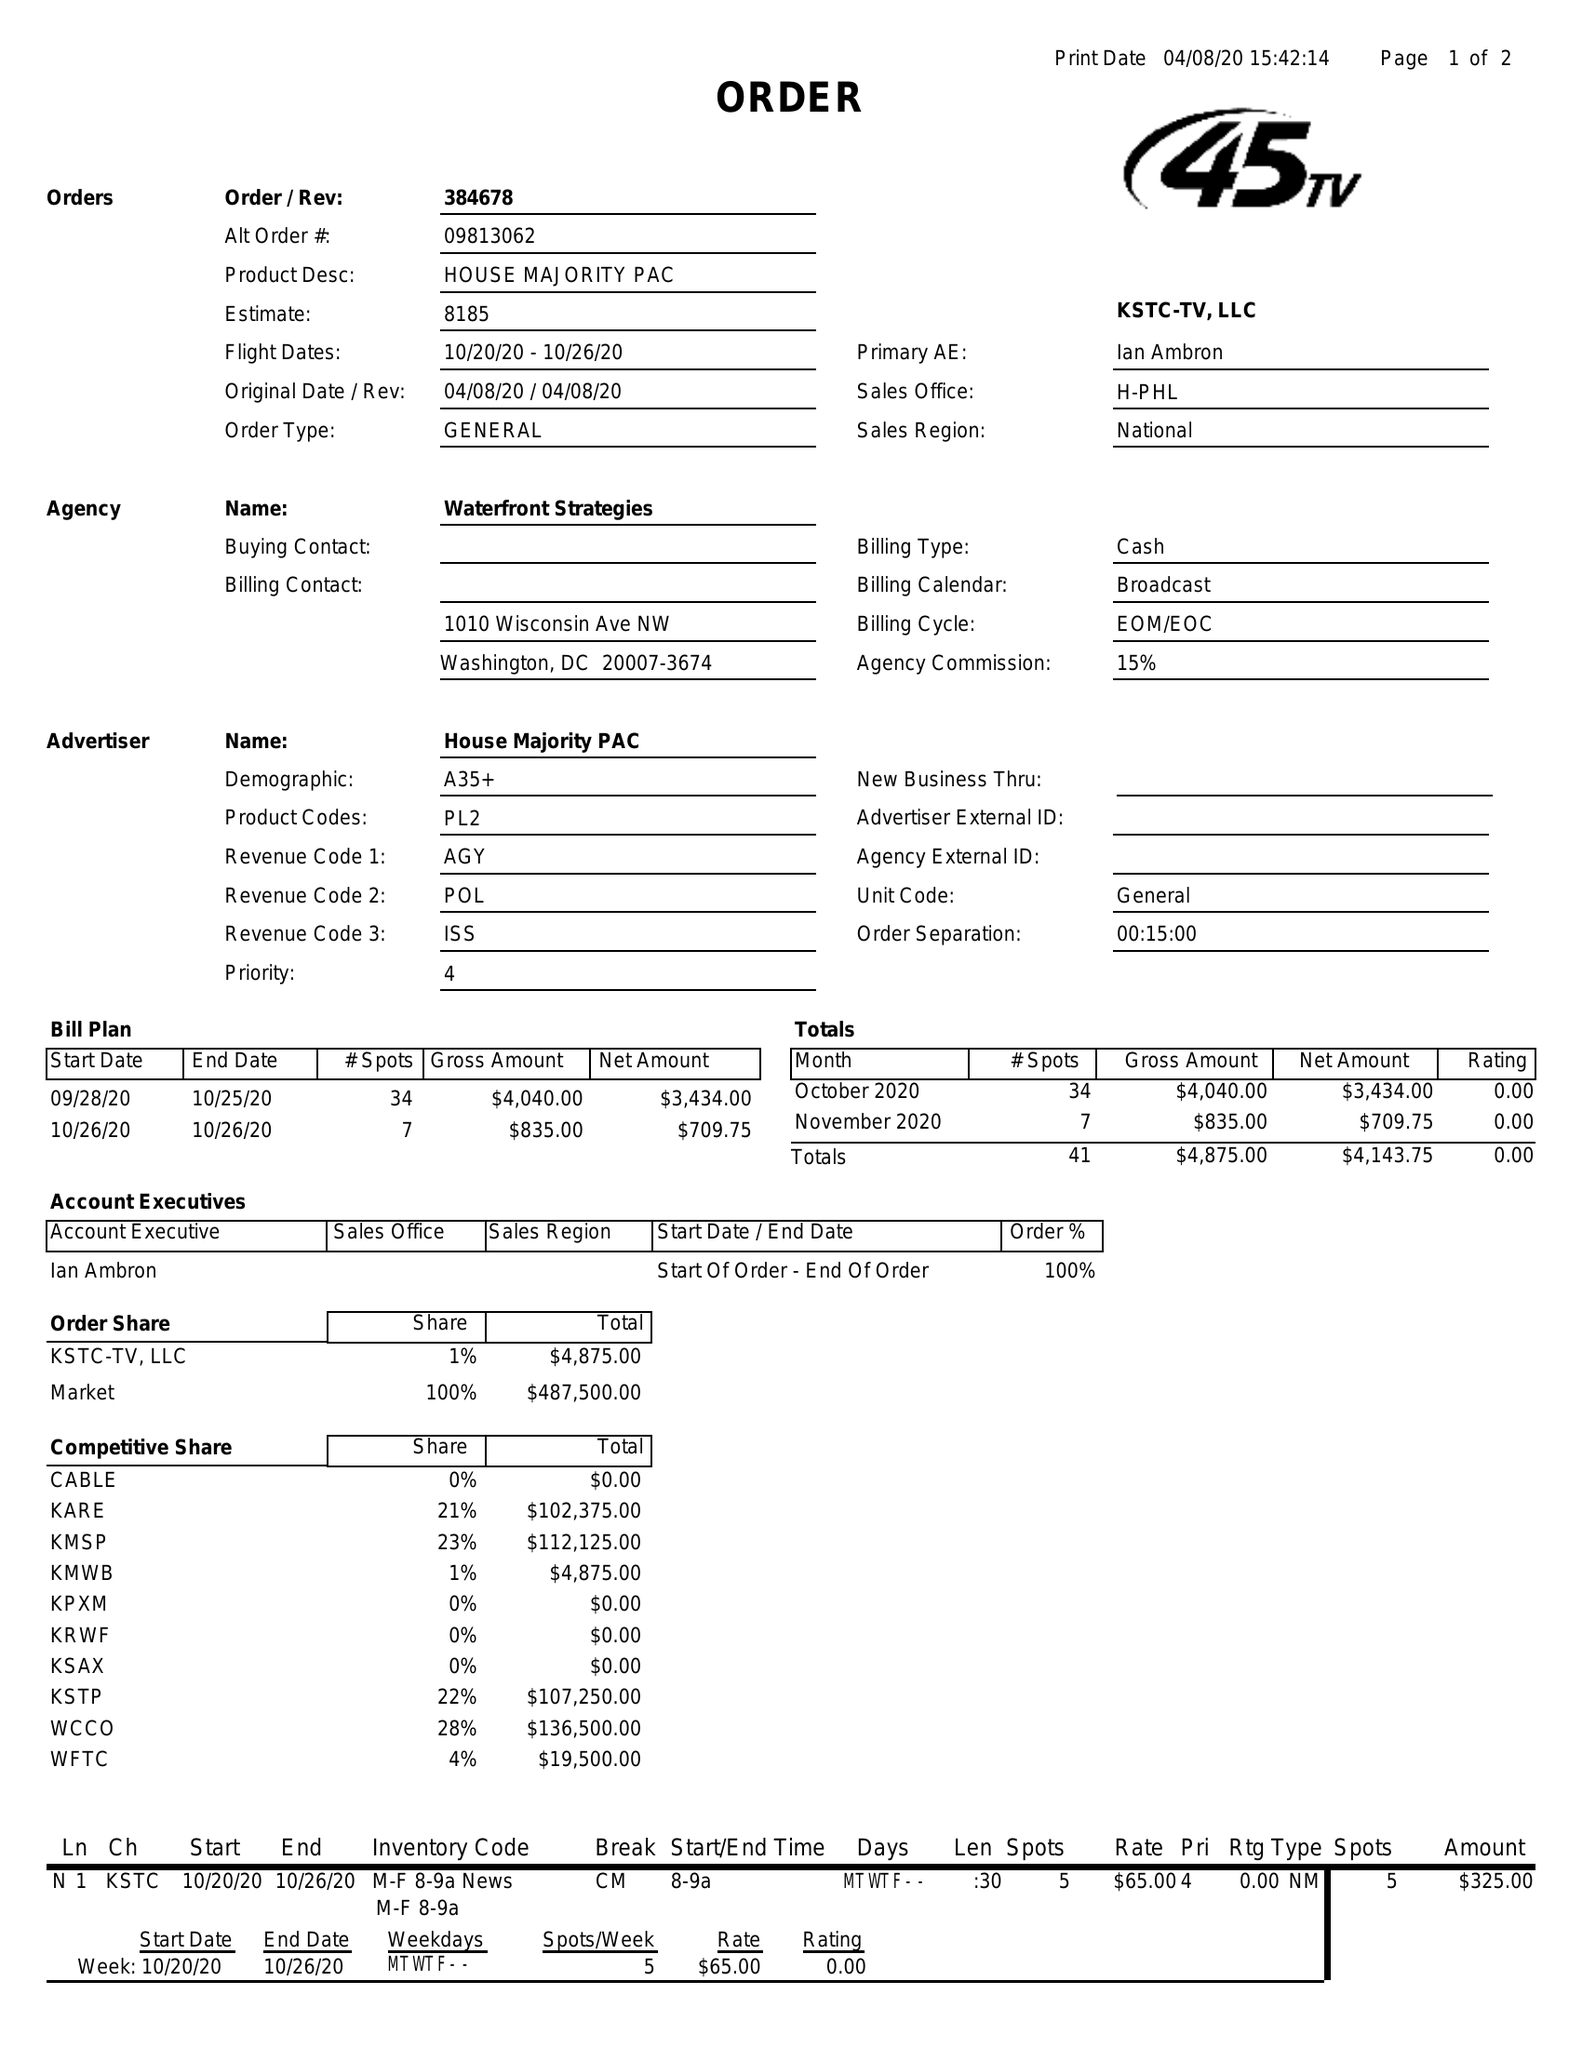What is the value for the advertiser?
Answer the question using a single word or phrase. HOUSE MAJORITY PAC 